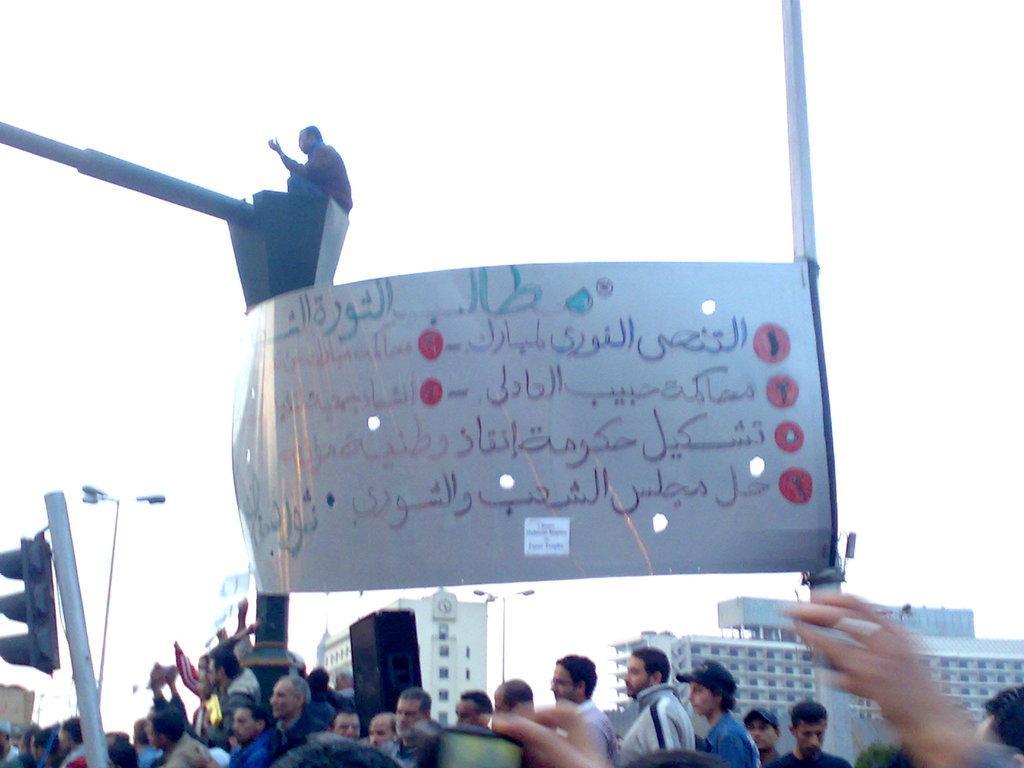Could you give a brief overview of what you see in this image? In the foreground I can see a crowd on the road, board, traffic poles and buildings. At the top I can see a person is sitting on a pole and the sky. This image is taken may be on the road. 